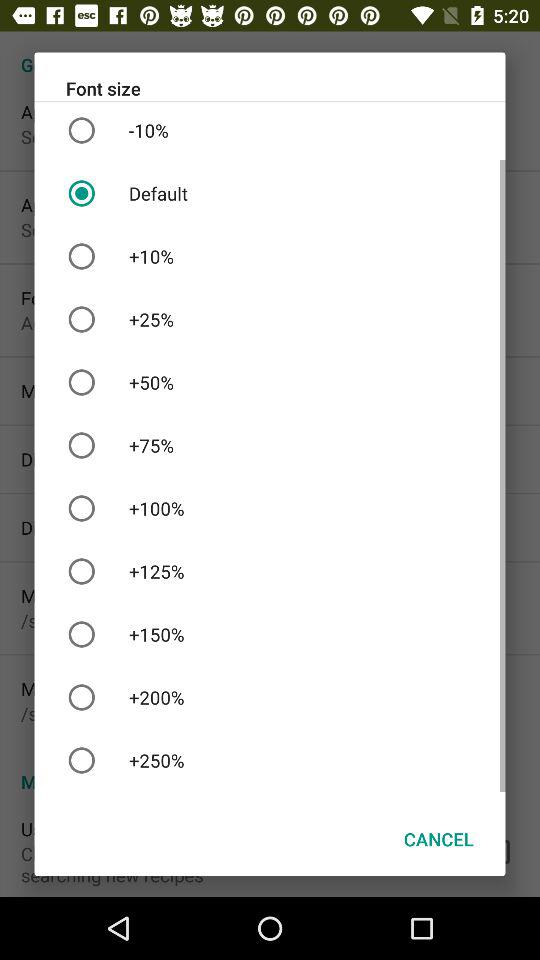Which font size was selected? The selected font size was the default. 